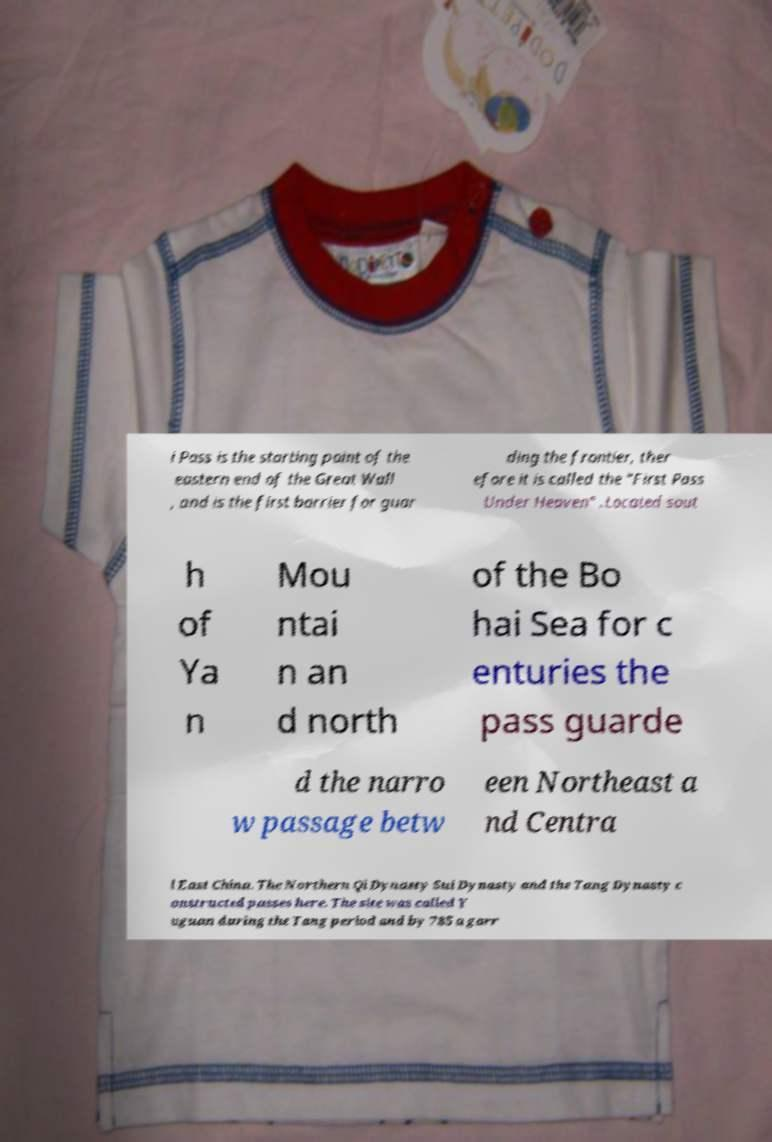Can you read and provide the text displayed in the image?This photo seems to have some interesting text. Can you extract and type it out for me? i Pass is the starting point of the eastern end of the Great Wall , and is the first barrier for guar ding the frontier, ther efore it is called the "First Pass Under Heaven" .Located sout h of Ya n Mou ntai n an d north of the Bo hai Sea for c enturies the pass guarde d the narro w passage betw een Northeast a nd Centra l East China. The Northern Qi Dynasty Sui Dynasty and the Tang Dynasty c onstructed passes here. The site was called Y uguan during the Tang period and by 785 a garr 